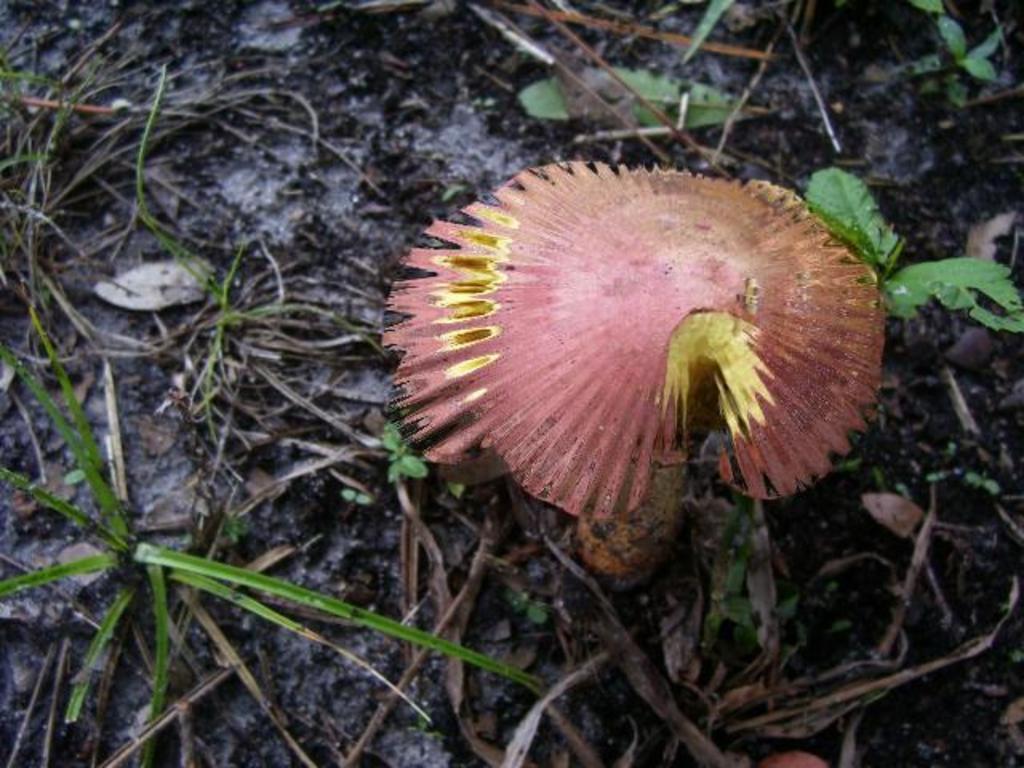Can you describe this image briefly? In this picture we can see a mushroom on the ground and beside this mushroom we can see grass. 